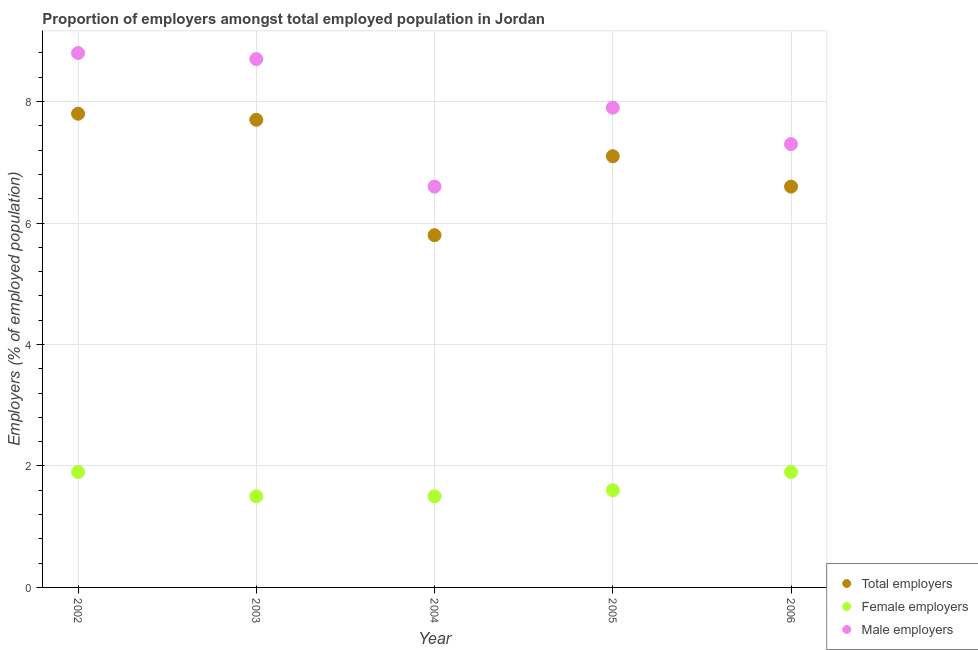What is the percentage of total employers in 2006?
Your answer should be very brief. 6.6. Across all years, what is the maximum percentage of female employers?
Provide a succinct answer. 1.9. Across all years, what is the minimum percentage of male employers?
Offer a very short reply. 6.6. In which year was the percentage of male employers maximum?
Your response must be concise. 2002. What is the total percentage of male employers in the graph?
Ensure brevity in your answer.  39.3. What is the difference between the percentage of male employers in 2002 and that in 2006?
Give a very brief answer. 1.5. What is the difference between the percentage of female employers in 2002 and the percentage of male employers in 2005?
Your answer should be compact. -6. What is the average percentage of male employers per year?
Ensure brevity in your answer.  7.86. In the year 2002, what is the difference between the percentage of female employers and percentage of total employers?
Provide a short and direct response. -5.9. What is the ratio of the percentage of male employers in 2003 to that in 2004?
Provide a succinct answer. 1.32. Is the percentage of male employers in 2004 less than that in 2005?
Give a very brief answer. Yes. What is the difference between the highest and the second highest percentage of total employers?
Your answer should be compact. 0.1. What is the difference between the highest and the lowest percentage of male employers?
Ensure brevity in your answer.  2.2. Is the sum of the percentage of total employers in 2003 and 2004 greater than the maximum percentage of female employers across all years?
Provide a succinct answer. Yes. Is the percentage of female employers strictly less than the percentage of male employers over the years?
Provide a succinct answer. Yes. Does the graph contain any zero values?
Ensure brevity in your answer.  No. Does the graph contain grids?
Give a very brief answer. Yes. Where does the legend appear in the graph?
Offer a terse response. Bottom right. How are the legend labels stacked?
Provide a short and direct response. Vertical. What is the title of the graph?
Give a very brief answer. Proportion of employers amongst total employed population in Jordan. What is the label or title of the Y-axis?
Make the answer very short. Employers (% of employed population). What is the Employers (% of employed population) of Total employers in 2002?
Ensure brevity in your answer.  7.8. What is the Employers (% of employed population) in Female employers in 2002?
Make the answer very short. 1.9. What is the Employers (% of employed population) of Male employers in 2002?
Your response must be concise. 8.8. What is the Employers (% of employed population) of Total employers in 2003?
Your response must be concise. 7.7. What is the Employers (% of employed population) of Male employers in 2003?
Give a very brief answer. 8.7. What is the Employers (% of employed population) in Total employers in 2004?
Make the answer very short. 5.8. What is the Employers (% of employed population) in Male employers in 2004?
Provide a succinct answer. 6.6. What is the Employers (% of employed population) in Total employers in 2005?
Your response must be concise. 7.1. What is the Employers (% of employed population) of Female employers in 2005?
Give a very brief answer. 1.6. What is the Employers (% of employed population) in Male employers in 2005?
Your answer should be very brief. 7.9. What is the Employers (% of employed population) in Total employers in 2006?
Your response must be concise. 6.6. What is the Employers (% of employed population) of Female employers in 2006?
Offer a very short reply. 1.9. What is the Employers (% of employed population) in Male employers in 2006?
Give a very brief answer. 7.3. Across all years, what is the maximum Employers (% of employed population) in Total employers?
Your answer should be very brief. 7.8. Across all years, what is the maximum Employers (% of employed population) in Female employers?
Your answer should be compact. 1.9. Across all years, what is the maximum Employers (% of employed population) of Male employers?
Keep it short and to the point. 8.8. Across all years, what is the minimum Employers (% of employed population) of Total employers?
Ensure brevity in your answer.  5.8. Across all years, what is the minimum Employers (% of employed population) of Male employers?
Ensure brevity in your answer.  6.6. What is the total Employers (% of employed population) in Total employers in the graph?
Make the answer very short. 35. What is the total Employers (% of employed population) of Female employers in the graph?
Provide a succinct answer. 8.4. What is the total Employers (% of employed population) in Male employers in the graph?
Your answer should be compact. 39.3. What is the difference between the Employers (% of employed population) of Male employers in 2002 and that in 2003?
Your response must be concise. 0.1. What is the difference between the Employers (% of employed population) in Total employers in 2002 and that in 2005?
Your response must be concise. 0.7. What is the difference between the Employers (% of employed population) of Male employers in 2002 and that in 2006?
Offer a very short reply. 1.5. What is the difference between the Employers (% of employed population) of Male employers in 2003 and that in 2004?
Ensure brevity in your answer.  2.1. What is the difference between the Employers (% of employed population) of Total employers in 2003 and that in 2005?
Offer a terse response. 0.6. What is the difference between the Employers (% of employed population) of Female employers in 2003 and that in 2005?
Offer a very short reply. -0.1. What is the difference between the Employers (% of employed population) in Male employers in 2003 and that in 2006?
Your answer should be very brief. 1.4. What is the difference between the Employers (% of employed population) in Total employers in 2004 and that in 2005?
Make the answer very short. -1.3. What is the difference between the Employers (% of employed population) of Male employers in 2004 and that in 2005?
Your answer should be compact. -1.3. What is the difference between the Employers (% of employed population) of Total employers in 2004 and that in 2006?
Give a very brief answer. -0.8. What is the difference between the Employers (% of employed population) of Total employers in 2005 and that in 2006?
Make the answer very short. 0.5. What is the difference between the Employers (% of employed population) in Female employers in 2002 and the Employers (% of employed population) in Male employers in 2003?
Offer a very short reply. -6.8. What is the difference between the Employers (% of employed population) of Total employers in 2002 and the Employers (% of employed population) of Male employers in 2004?
Ensure brevity in your answer.  1.2. What is the difference between the Employers (% of employed population) in Total employers in 2002 and the Employers (% of employed population) in Female employers in 2005?
Your answer should be compact. 6.2. What is the difference between the Employers (% of employed population) in Total employers in 2002 and the Employers (% of employed population) in Female employers in 2006?
Offer a terse response. 5.9. What is the difference between the Employers (% of employed population) in Female employers in 2002 and the Employers (% of employed population) in Male employers in 2006?
Ensure brevity in your answer.  -5.4. What is the difference between the Employers (% of employed population) in Total employers in 2003 and the Employers (% of employed population) in Male employers in 2004?
Offer a terse response. 1.1. What is the difference between the Employers (% of employed population) in Female employers in 2003 and the Employers (% of employed population) in Male employers in 2004?
Your response must be concise. -5.1. What is the difference between the Employers (% of employed population) in Total employers in 2003 and the Employers (% of employed population) in Female employers in 2005?
Your response must be concise. 6.1. What is the difference between the Employers (% of employed population) in Total employers in 2003 and the Employers (% of employed population) in Male employers in 2005?
Provide a succinct answer. -0.2. What is the difference between the Employers (% of employed population) of Total employers in 2003 and the Employers (% of employed population) of Female employers in 2006?
Keep it short and to the point. 5.8. What is the difference between the Employers (% of employed population) of Total employers in 2004 and the Employers (% of employed population) of Female employers in 2005?
Keep it short and to the point. 4.2. What is the difference between the Employers (% of employed population) in Female employers in 2004 and the Employers (% of employed population) in Male employers in 2005?
Your answer should be very brief. -6.4. What is the difference between the Employers (% of employed population) of Total employers in 2004 and the Employers (% of employed population) of Male employers in 2006?
Your answer should be compact. -1.5. What is the difference between the Employers (% of employed population) in Total employers in 2005 and the Employers (% of employed population) in Male employers in 2006?
Ensure brevity in your answer.  -0.2. What is the difference between the Employers (% of employed population) in Female employers in 2005 and the Employers (% of employed population) in Male employers in 2006?
Give a very brief answer. -5.7. What is the average Employers (% of employed population) in Female employers per year?
Your answer should be compact. 1.68. What is the average Employers (% of employed population) of Male employers per year?
Provide a short and direct response. 7.86. In the year 2002, what is the difference between the Employers (% of employed population) in Total employers and Employers (% of employed population) in Female employers?
Your answer should be compact. 5.9. In the year 2003, what is the difference between the Employers (% of employed population) in Total employers and Employers (% of employed population) in Male employers?
Provide a succinct answer. -1. In the year 2003, what is the difference between the Employers (% of employed population) in Female employers and Employers (% of employed population) in Male employers?
Your response must be concise. -7.2. In the year 2004, what is the difference between the Employers (% of employed population) of Total employers and Employers (% of employed population) of Male employers?
Provide a succinct answer. -0.8. In the year 2004, what is the difference between the Employers (% of employed population) of Female employers and Employers (% of employed population) of Male employers?
Ensure brevity in your answer.  -5.1. In the year 2005, what is the difference between the Employers (% of employed population) of Total employers and Employers (% of employed population) of Female employers?
Make the answer very short. 5.5. In the year 2005, what is the difference between the Employers (% of employed population) of Total employers and Employers (% of employed population) of Male employers?
Offer a very short reply. -0.8. In the year 2005, what is the difference between the Employers (% of employed population) of Female employers and Employers (% of employed population) of Male employers?
Keep it short and to the point. -6.3. In the year 2006, what is the difference between the Employers (% of employed population) of Total employers and Employers (% of employed population) of Male employers?
Your answer should be compact. -0.7. In the year 2006, what is the difference between the Employers (% of employed population) of Female employers and Employers (% of employed population) of Male employers?
Give a very brief answer. -5.4. What is the ratio of the Employers (% of employed population) of Female employers in 2002 to that in 2003?
Provide a succinct answer. 1.27. What is the ratio of the Employers (% of employed population) of Male employers in 2002 to that in 2003?
Provide a short and direct response. 1.01. What is the ratio of the Employers (% of employed population) of Total employers in 2002 to that in 2004?
Keep it short and to the point. 1.34. What is the ratio of the Employers (% of employed population) in Female employers in 2002 to that in 2004?
Your answer should be compact. 1.27. What is the ratio of the Employers (% of employed population) in Total employers in 2002 to that in 2005?
Provide a succinct answer. 1.1. What is the ratio of the Employers (% of employed population) in Female employers in 2002 to that in 2005?
Offer a terse response. 1.19. What is the ratio of the Employers (% of employed population) of Male employers in 2002 to that in 2005?
Offer a terse response. 1.11. What is the ratio of the Employers (% of employed population) in Total employers in 2002 to that in 2006?
Provide a succinct answer. 1.18. What is the ratio of the Employers (% of employed population) of Female employers in 2002 to that in 2006?
Keep it short and to the point. 1. What is the ratio of the Employers (% of employed population) of Male employers in 2002 to that in 2006?
Provide a short and direct response. 1.21. What is the ratio of the Employers (% of employed population) of Total employers in 2003 to that in 2004?
Your response must be concise. 1.33. What is the ratio of the Employers (% of employed population) in Female employers in 2003 to that in 2004?
Give a very brief answer. 1. What is the ratio of the Employers (% of employed population) of Male employers in 2003 to that in 2004?
Offer a very short reply. 1.32. What is the ratio of the Employers (% of employed population) of Total employers in 2003 to that in 2005?
Provide a short and direct response. 1.08. What is the ratio of the Employers (% of employed population) in Female employers in 2003 to that in 2005?
Make the answer very short. 0.94. What is the ratio of the Employers (% of employed population) in Male employers in 2003 to that in 2005?
Make the answer very short. 1.1. What is the ratio of the Employers (% of employed population) in Female employers in 2003 to that in 2006?
Offer a terse response. 0.79. What is the ratio of the Employers (% of employed population) of Male employers in 2003 to that in 2006?
Make the answer very short. 1.19. What is the ratio of the Employers (% of employed population) of Total employers in 2004 to that in 2005?
Provide a succinct answer. 0.82. What is the ratio of the Employers (% of employed population) of Male employers in 2004 to that in 2005?
Keep it short and to the point. 0.84. What is the ratio of the Employers (% of employed population) of Total employers in 2004 to that in 2006?
Give a very brief answer. 0.88. What is the ratio of the Employers (% of employed population) of Female employers in 2004 to that in 2006?
Provide a short and direct response. 0.79. What is the ratio of the Employers (% of employed population) in Male employers in 2004 to that in 2006?
Ensure brevity in your answer.  0.9. What is the ratio of the Employers (% of employed population) of Total employers in 2005 to that in 2006?
Ensure brevity in your answer.  1.08. What is the ratio of the Employers (% of employed population) of Female employers in 2005 to that in 2006?
Offer a terse response. 0.84. What is the ratio of the Employers (% of employed population) in Male employers in 2005 to that in 2006?
Ensure brevity in your answer.  1.08. What is the difference between the highest and the second highest Employers (% of employed population) in Male employers?
Offer a terse response. 0.1. 